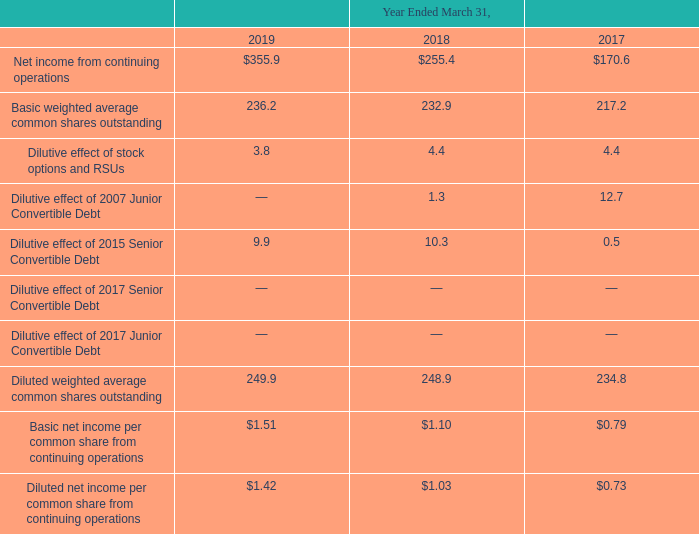Note 20. Net Income Per Common Share From Continuing Operations
The following table sets forth the computation of basic and diluted net income per common share from continuing operations (in millions, except per share amounts):
The Company computed basic net income per common share from continuing operations based on the weighted average number of common shares outstanding during the period. The Company computed diluted net income per common share from continuing operations based on the weighted average number of common shares outstanding plus potentially dilutive common shares outstanding during the period.
Potentially dilutive common shares from employee equity incentive plans are determined by applying the treasury stock method to the assumed exercise of outstanding stock options and the assumed vesting of outstanding RSUs. Weighted average common shares exclude the effect of option shares which are not dilutive. There were no anti-dilutive option shares for the years ended March 31, 2019, 2018, and 2017.
Which years does the table provide information for the computation of basic and diluted net income per common share from continuing operations? 2019, 2018, 2017. What was the Net income from continuing operations in 2017?
Answer scale should be: million. 170.6. What was the Dilutive effect of stock options and RSUs in 2019?
Answer scale should be: million. 3.8. How many years did the Dilutive effect of stock options and RSUs exceed $4 million? 2018##2017
Answer: 2. What was the change in Net income from continuing operations between 2017 and 2018?
Answer scale should be: million. 255.4-170.6
Answer: 84.8. What was the percentage change in the Basic net income per common share from continuing operations between 2018 and 2019?
Answer scale should be: percent. (1.51-1.10)/1.10
Answer: 37.27. 